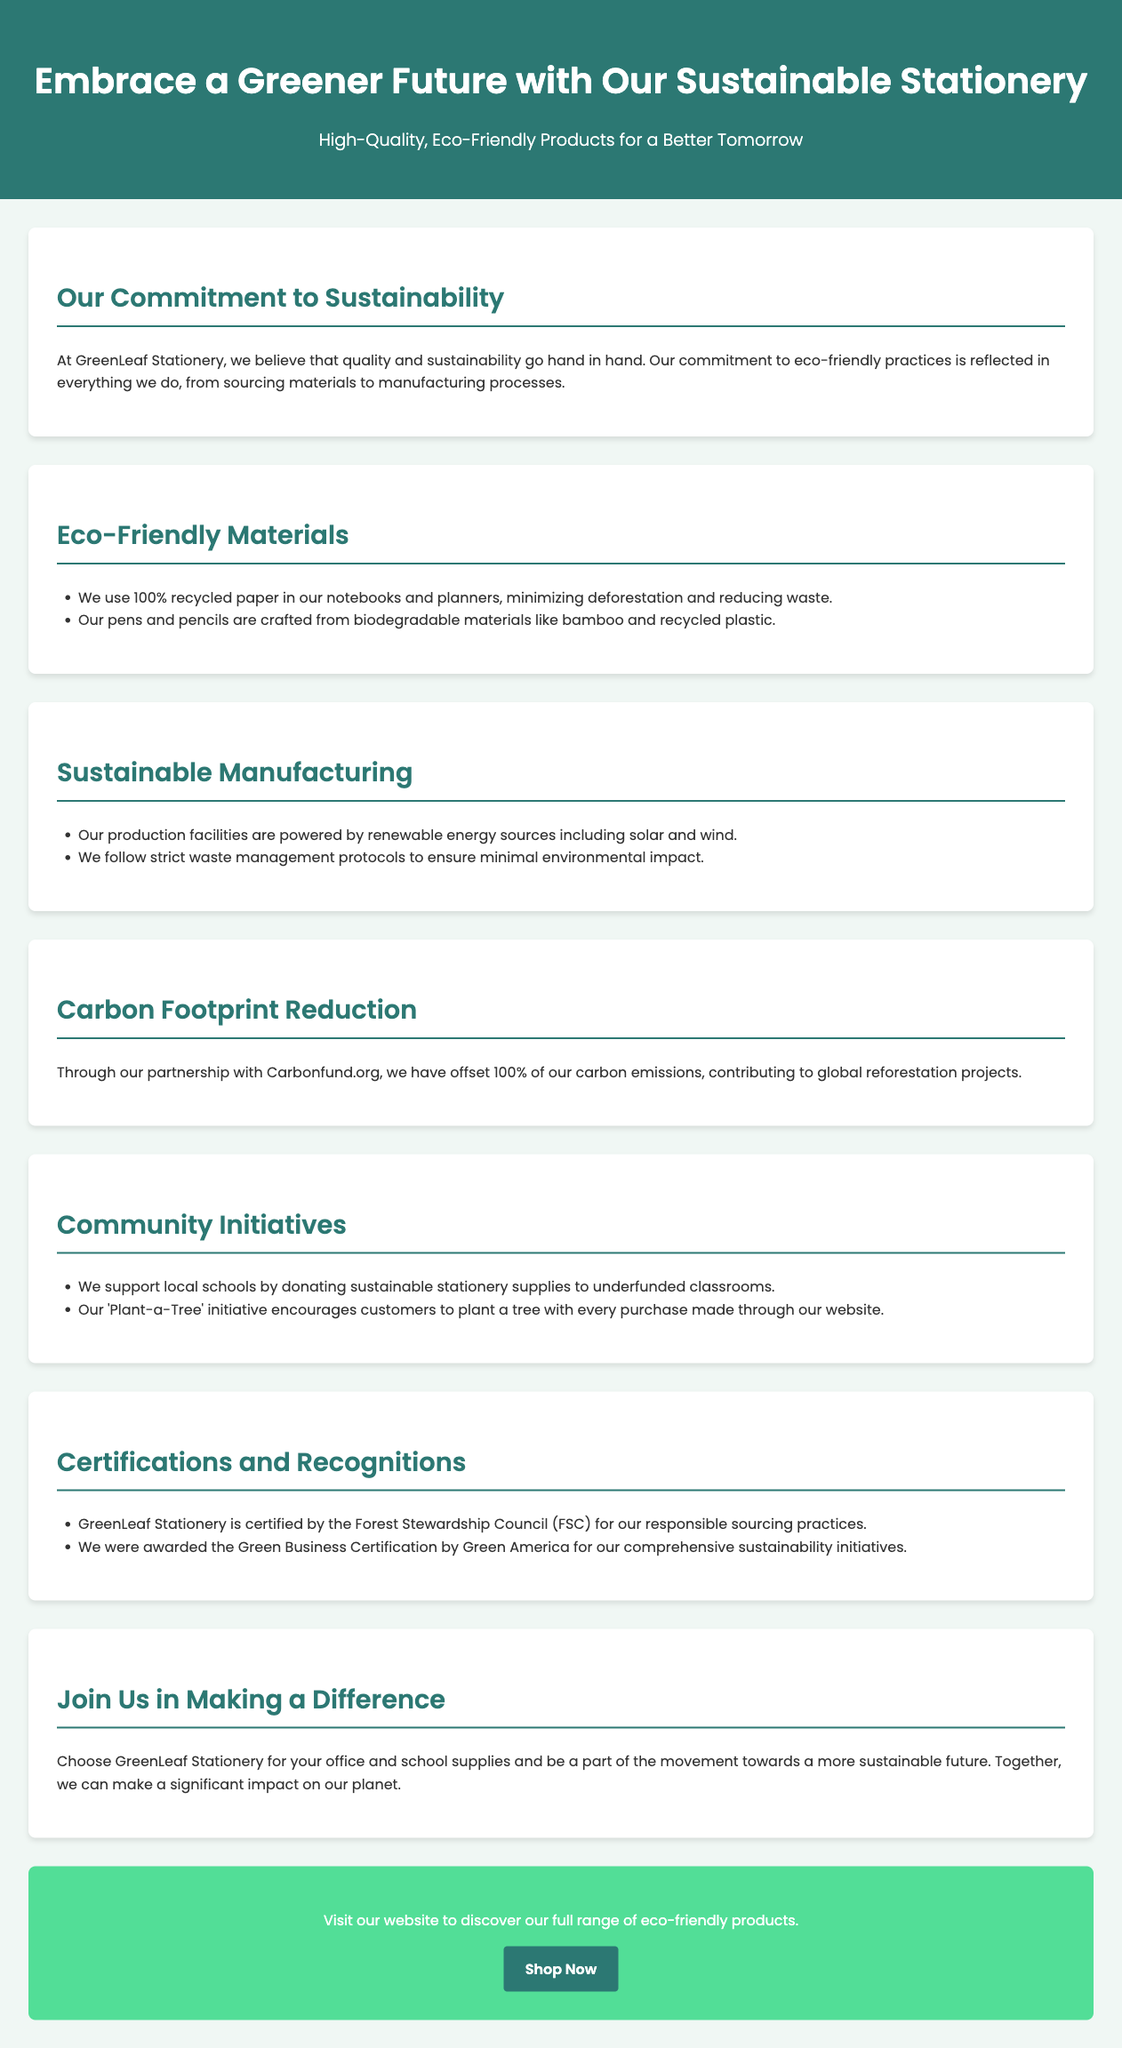What is the company name? The company name mentioned in the document is located at the top header section.
Answer: GreenLeaf Stationery What percentage of recycled paper is used? The document specifies the type of paper used in notebooks and planners directly in the eco-friendly materials section.
Answer: 100% Which materials are pens and pencils made from? The section on eco-friendly materials lists the materials used for pens and pencils.
Answer: Biodegradable materials What is the partnership organization for carbon offsetting? The document indicates the organization partnered with for carbon offsetting in the carbon footprint reduction section.
Answer: Carbonfund.org What initiative supports local schools? The community initiatives section describes the support given to local schools explicitly.
Answer: Donating sustainable stationery supplies Which certification is mentioned for responsible sourcing? The certifications section lists the certification received for sourcing practices.
Answer: Forest Stewardship Council (FSC) What is the impact of every purchase made through the website? The document explains the purpose of the 'Plant-a-Tree' initiative tied to customer purchases in the community initiatives section.
Answer: Plant a tree How is the production facility powered? The sustainable manufacturing section specifies the energy sources used at the production facilities.
Answer: Renewable energy sources What type of certification did GreenLeaf Stationery receive from Green America? The document highlights the specific certification awarded in the certifications section.
Answer: Green Business Certification 